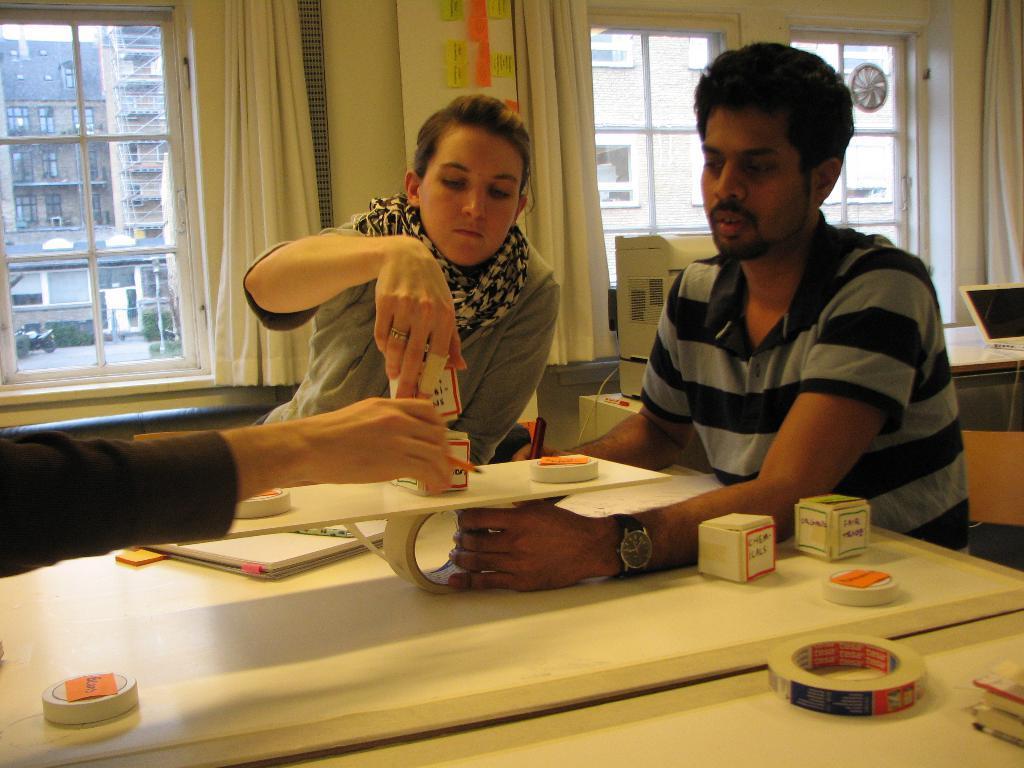Could you give a brief overview of what you see in this image? This image is taken inside a room. There are three people in this room. In the right side of the image a man is sitting on a chair and holding a plaster. In the middle of the image a woman is sitting on a chair. At the background there are windows curtains and walls. At the bottom of the image there is a table and there were few things on it. 